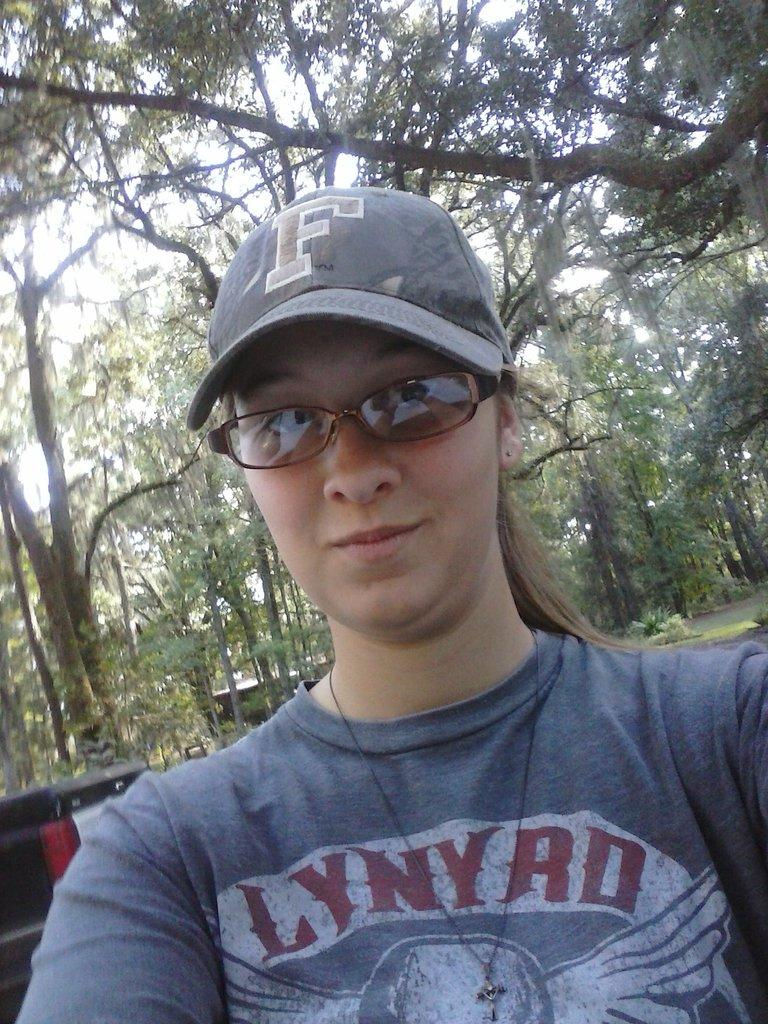Who is the main subject in the image? There is a lady in the image. What is the lady wearing on her head? The lady is wearing a cap. What accessory is the lady wearing on her face? The lady is wearing glasses. What can be seen behind the lady in the image? There are objects visible behind the lady. What type of natural scenery is visible in the background? There are trees visible in the background. How many passengers are visible in the image? There are no passengers visible in the image; it features a lady wearing a cap and glasses. What type of farming equipment is being used in the image? There is no farming equipment present in the image. 